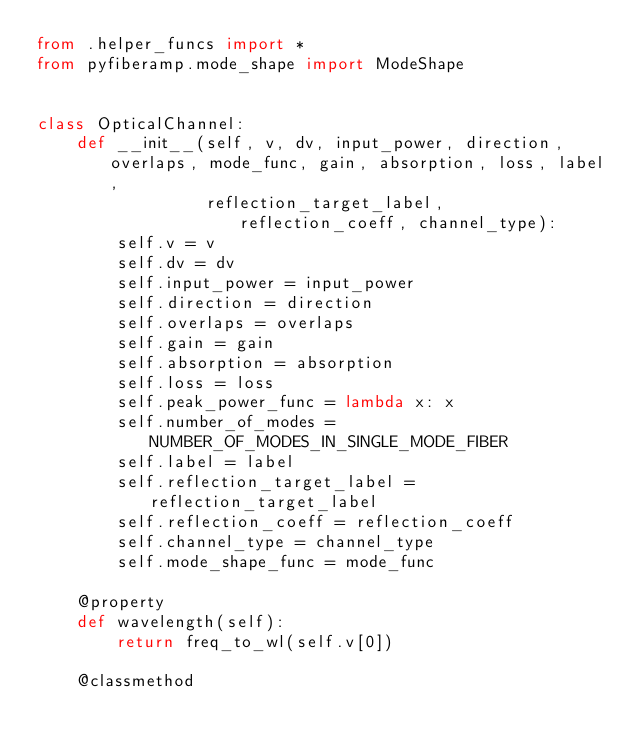Convert code to text. <code><loc_0><loc_0><loc_500><loc_500><_Python_>from .helper_funcs import *
from pyfiberamp.mode_shape import ModeShape


class OpticalChannel:
    def __init__(self, v, dv, input_power, direction, overlaps, mode_func, gain, absorption, loss, label,
                 reflection_target_label, reflection_coeff, channel_type):
        self.v = v
        self.dv = dv
        self.input_power = input_power
        self.direction = direction
        self.overlaps = overlaps
        self.gain = gain
        self.absorption = absorption
        self.loss = loss
        self.peak_power_func = lambda x: x
        self.number_of_modes = NUMBER_OF_MODES_IN_SINGLE_MODE_FIBER
        self.label = label
        self.reflection_target_label = reflection_target_label
        self.reflection_coeff = reflection_coeff
        self.channel_type = channel_type
        self.mode_shape_func = mode_func

    @property
    def wavelength(self):
        return freq_to_wl(self.v[0])

    @classmethod</code> 